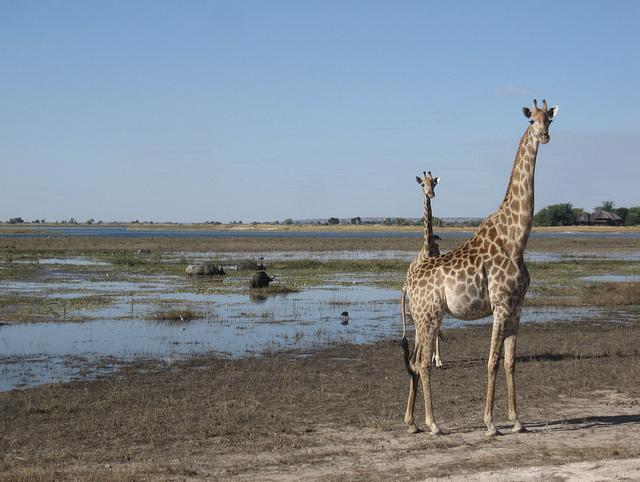The giraffe in the front is probably related to the one behind in what way? Please explain your reasoning. parent. The bigger giraffe is probably the mom. 